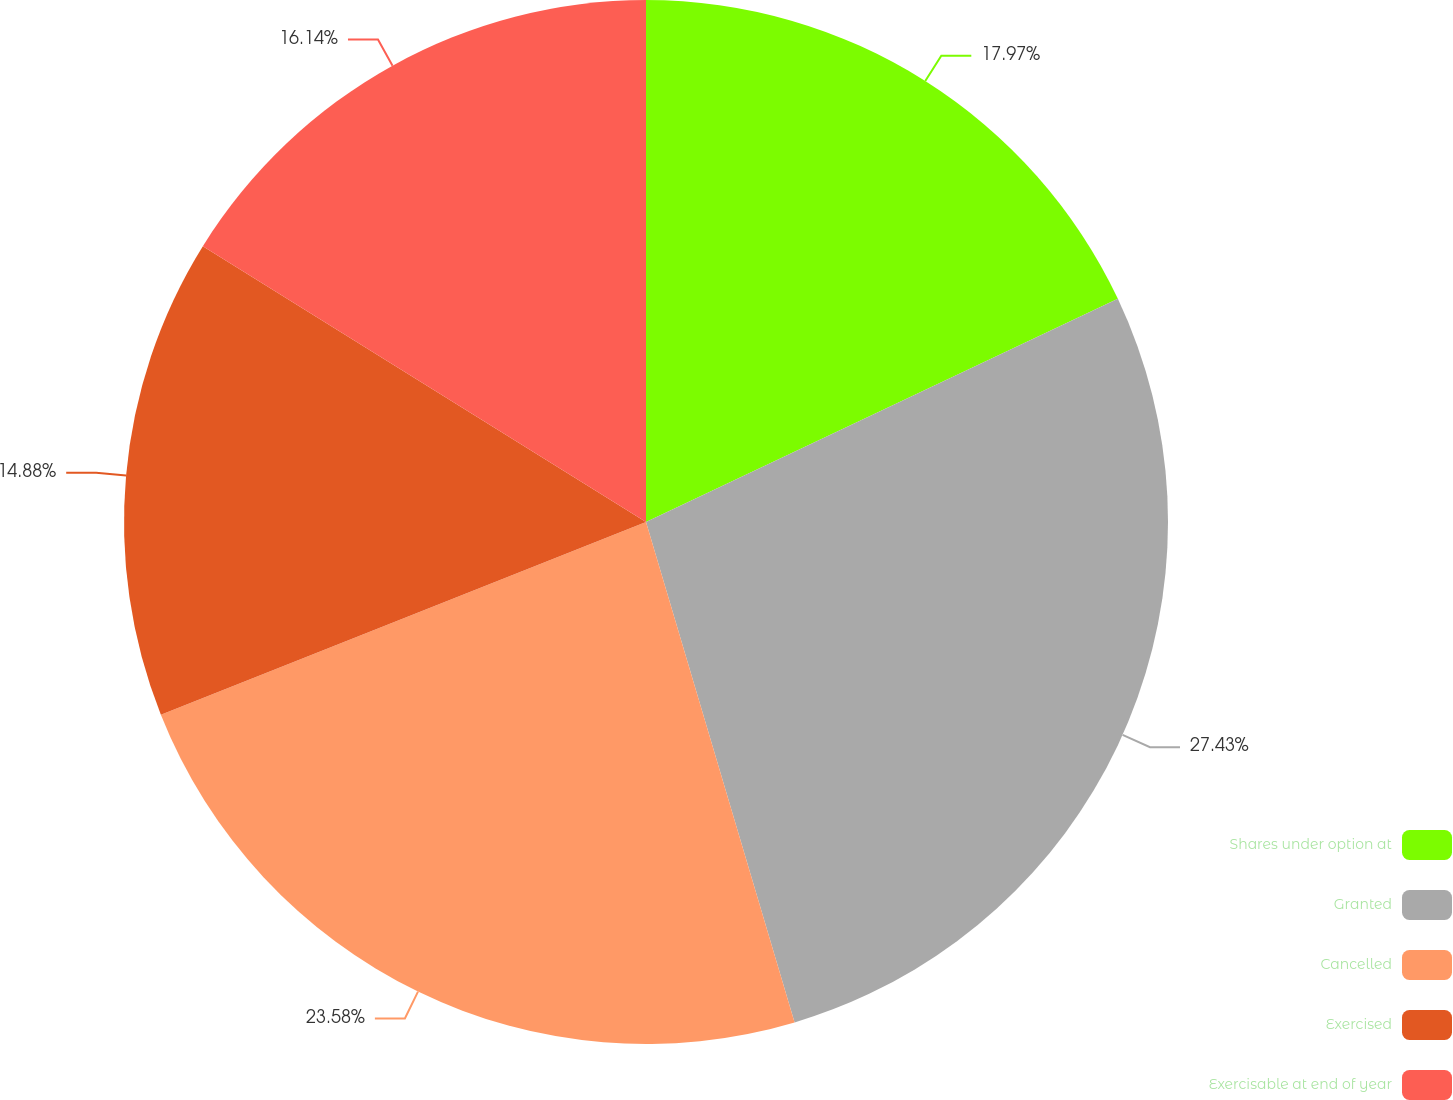Convert chart to OTSL. <chart><loc_0><loc_0><loc_500><loc_500><pie_chart><fcel>Shares under option at<fcel>Granted<fcel>Cancelled<fcel>Exercised<fcel>Exercisable at end of year<nl><fcel>17.97%<fcel>27.44%<fcel>23.58%<fcel>14.88%<fcel>16.14%<nl></chart> 